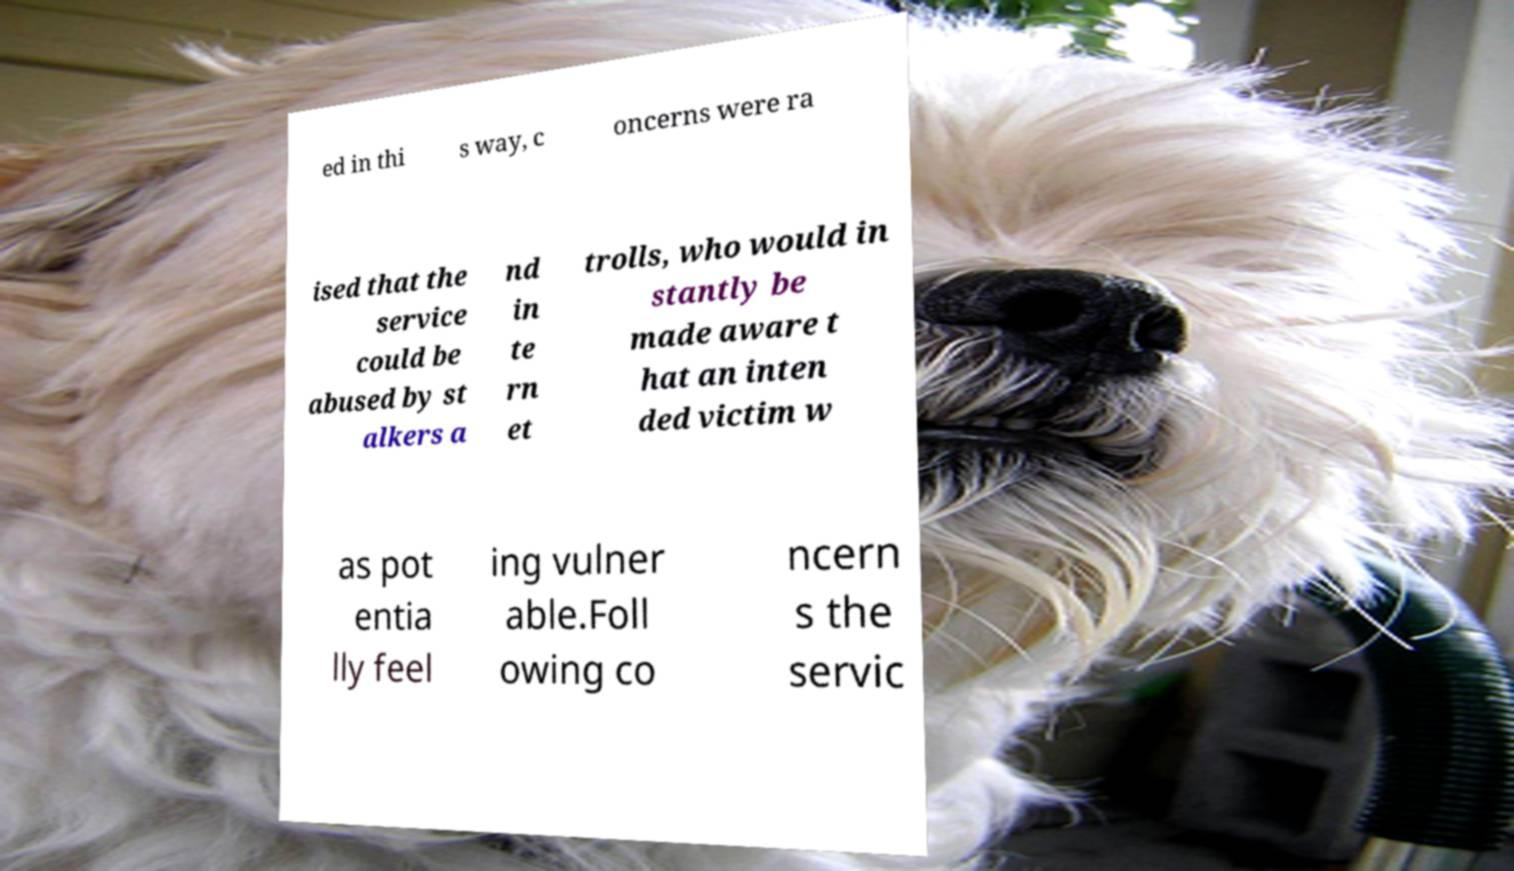Please identify and transcribe the text found in this image. ed in thi s way, c oncerns were ra ised that the service could be abused by st alkers a nd in te rn et trolls, who would in stantly be made aware t hat an inten ded victim w as pot entia lly feel ing vulner able.Foll owing co ncern s the servic 